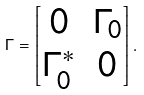Convert formula to latex. <formula><loc_0><loc_0><loc_500><loc_500>\Gamma = \begin{bmatrix} 0 & \Gamma _ { 0 } \\ \Gamma _ { 0 } ^ { * } & 0 \end{bmatrix} .</formula> 